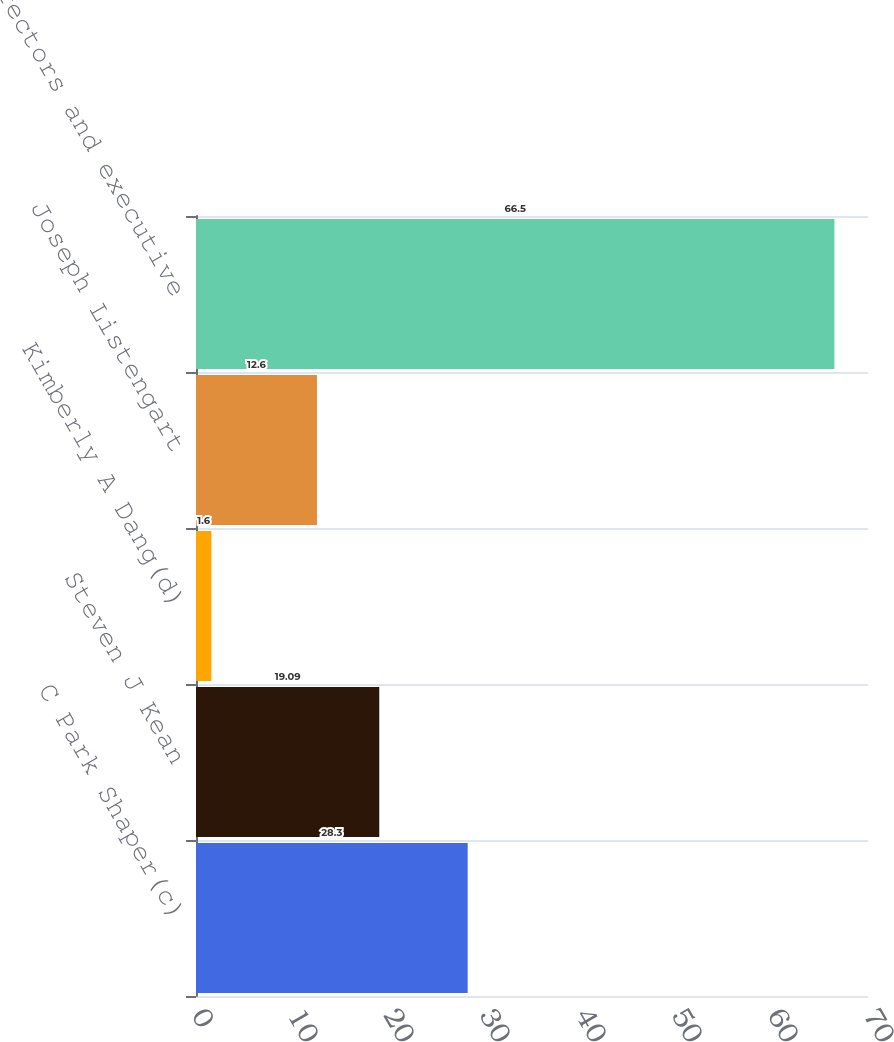Convert chart to OTSL. <chart><loc_0><loc_0><loc_500><loc_500><bar_chart><fcel>C Park Shaper(c)<fcel>Steven J Kean<fcel>Kimberly A Dang(d)<fcel>Joseph Listengart<fcel>Directors and executive<nl><fcel>28.3<fcel>19.09<fcel>1.6<fcel>12.6<fcel>66.5<nl></chart> 